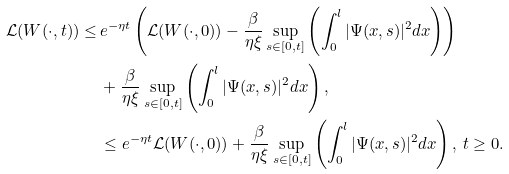Convert formula to latex. <formula><loc_0><loc_0><loc_500><loc_500>\mathcal { L } ( W ( \cdot , t ) ) \leq & \, e ^ { - \eta t } \left ( \mathcal { L } ( W ( \cdot , 0 ) ) - \frac { \beta } { \eta \xi } \sup _ { s \in [ 0 , t ] } \left ( \int _ { 0 } ^ { l } | \Psi ( x , s ) | ^ { 2 } d x \right ) \right ) \\ & \, + \frac { \beta } { \eta \xi } \sup _ { s \in [ 0 , t ] } \left ( \int _ { 0 } ^ { l } | \Psi ( x , s ) | ^ { 2 } d x \right ) , \\ & \, \leq e ^ { - \eta t } \mathcal { L } ( W ( \cdot , 0 ) ) + \frac { \beta } { \eta \xi } \sup _ { s \in [ 0 , t ] } \left ( \int _ { 0 } ^ { l } | \Psi ( x , s ) | ^ { 2 } d x \right ) , \, t \geq 0 .</formula> 